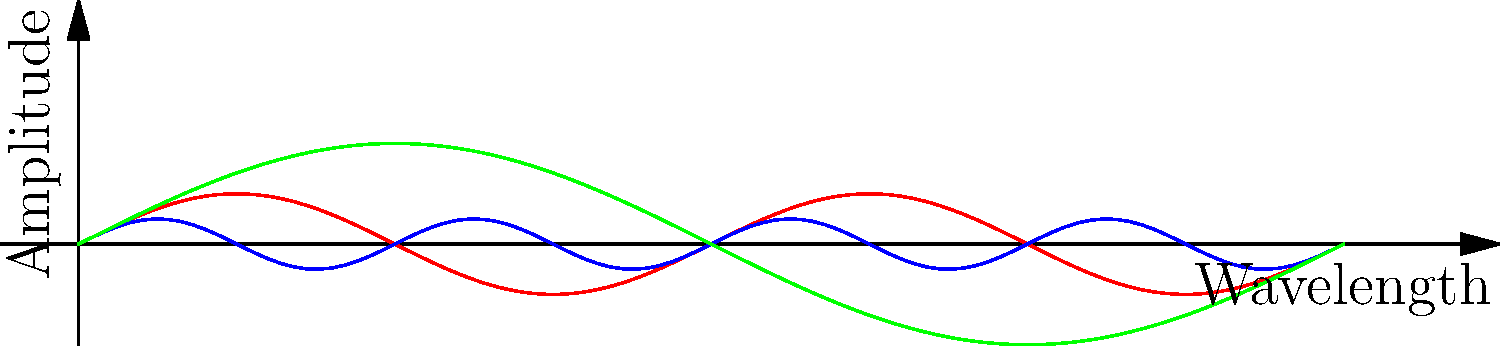In the context of media bias and propaganda, understanding the properties of electromagnetic waves is crucial for critically analyzing information about communication technologies. Based on the graph showing three types of electromagnetic waves (radio waves, X-rays, and infrared), which wave has the highest frequency and smallest wavelength? To determine which wave has the highest frequency and smallest wavelength, we need to analyze the graph and recall the relationship between wavelength, frequency, and wave properties:

1. Wavelength is represented by the horizontal axis. A shorter wavelength means more cycles within the same distance.
2. Frequency is inversely proportional to wavelength. Higher frequency corresponds to shorter wavelength.
3. In the graph:
   - Red curve (Radio waves): Has the longest wavelength (fewest cycles in the given range).
   - Blue curve (X-rays): Has the shortest wavelength (most cycles in the given range).
   - Green curve (Infrared): Has a wavelength between radio waves and X-rays.

4. The blue curve (X-rays) completes the most cycles within the given range, indicating it has the shortest wavelength.
5. Since frequency is inversely proportional to wavelength, the wave with the shortest wavelength (X-rays) also has the highest frequency.

This understanding is important for critically evaluating claims about communication technologies, radiation risks, and other topics that might be subject to media bias or propaganda.
Answer: X-rays 